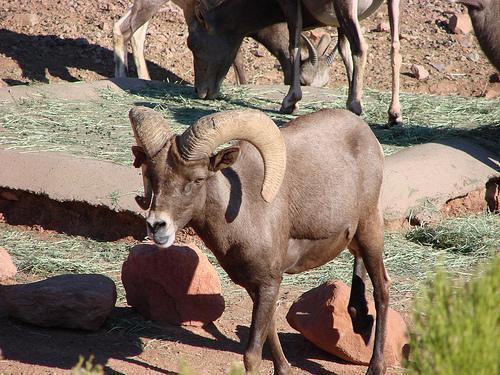How many white cows are there?
Give a very brief answer. 0. 